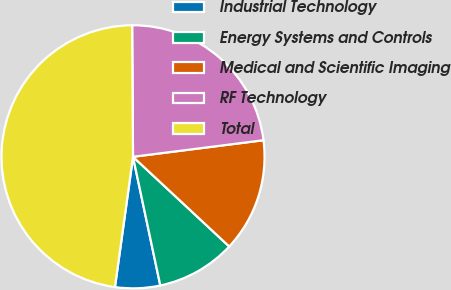Convert chart to OTSL. <chart><loc_0><loc_0><loc_500><loc_500><pie_chart><fcel>Industrial Technology<fcel>Energy Systems and Controls<fcel>Medical and Scientific Imaging<fcel>RF Technology<fcel>Total<nl><fcel>5.52%<fcel>9.73%<fcel>13.95%<fcel>23.09%<fcel>47.7%<nl></chart> 